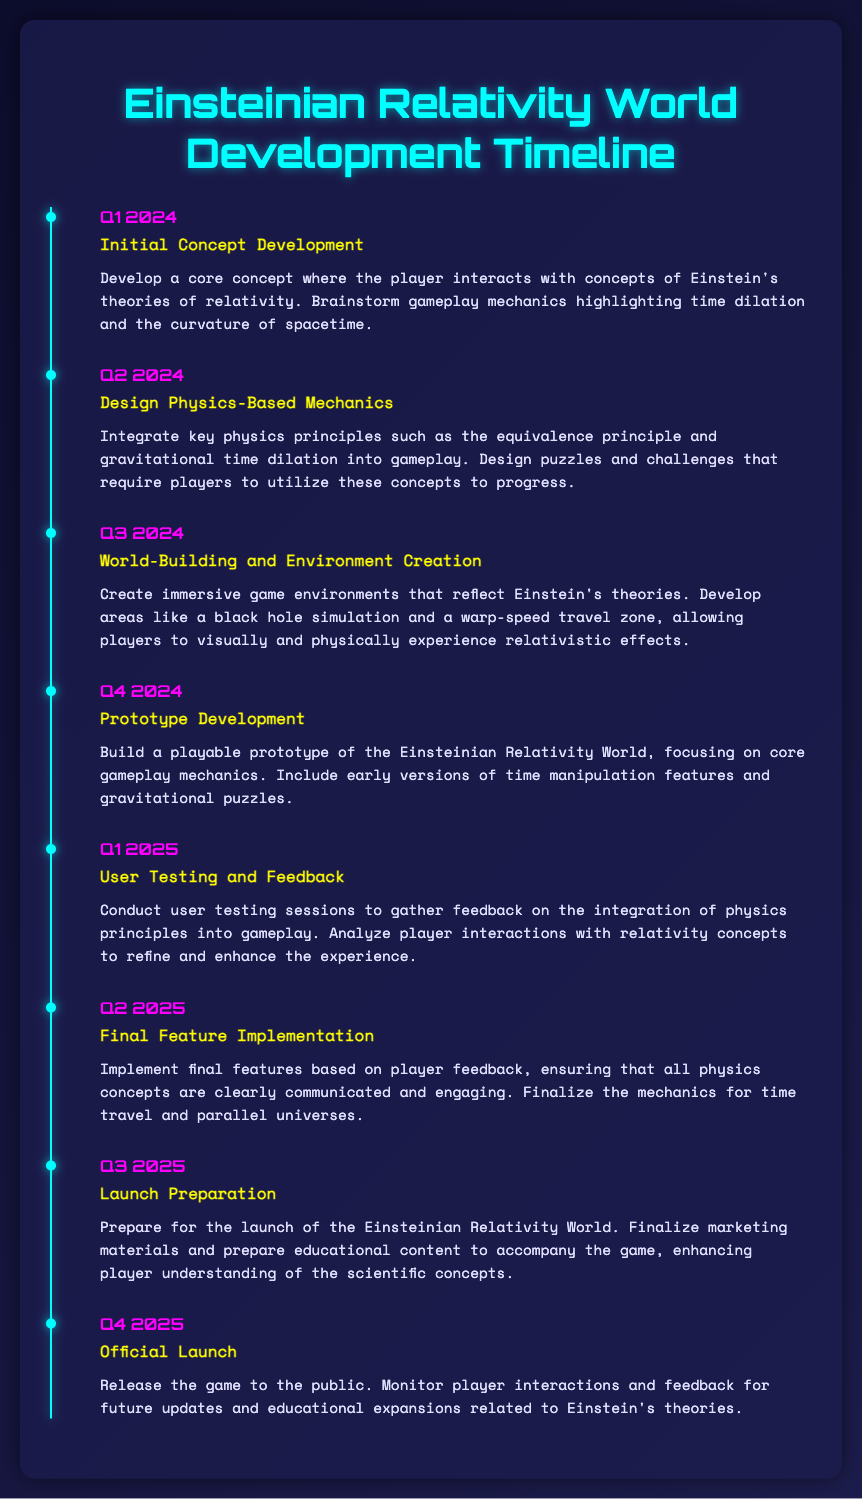What is the title of the document? The title of the document is specified in the header section, indicating the content is focused on the development timeline for the game.
Answer: Einsteinian Relativity World Development Timeline What is the first milestone in the timeline? The first milestone listed in the timeline is the initial concept development that takes place in the first quarter of 2024.
Answer: Initial Concept Development Which key physics principle is integrated into gameplay in Q2 2024? The specific principle mentioned for gameplay integration in Q2 2024 is the equivalence principle.
Answer: Equivalence principle What is the focus of the Q4 2024 milestone? This milestone, known as Prototype Development, focuses on building a playable version that highlights core gameplay features.
Answer: Prototype Development When is the official launch scheduled? The official launch date is provided in Q4 2025, indicating when the game will be released to the public.
Answer: Q4 2025 What type of user feedback is mentioned in Q1 2025? The user feedback refers to the effectiveness of integrating physics principles into the gameplay experience.
Answer: Physics principles In what quarter will the final features implementation occur? The final feature implementation is scheduled for completion in Q2 2025.
Answer: Q2 2025 Name one immersive game environment to be created in Q3 2024. The document specifies a black hole simulation as one of the immersive environments.
Answer: Black hole simulation What is emphasized in the marketing preparations before launch? The marketing preparations are focused on finalizing materials and creating educational content to accompany the game.
Answer: Educational content 